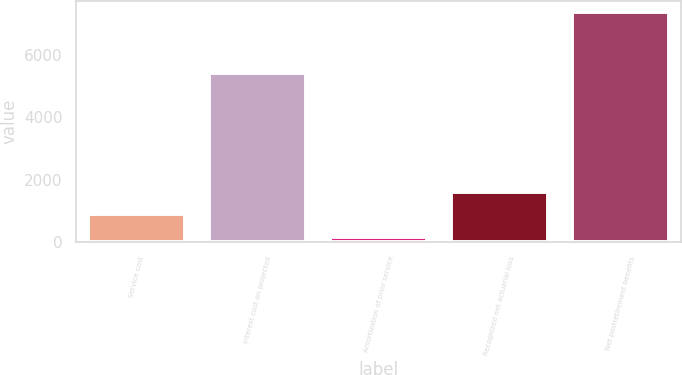Convert chart to OTSL. <chart><loc_0><loc_0><loc_500><loc_500><bar_chart><fcel>Service cost<fcel>Interest cost on projected<fcel>Amortization of prior service<fcel>Recognized net actuarial loss<fcel>Net postretirement benefits<nl><fcel>889.4<fcel>5426<fcel>170<fcel>1608.8<fcel>7364<nl></chart> 